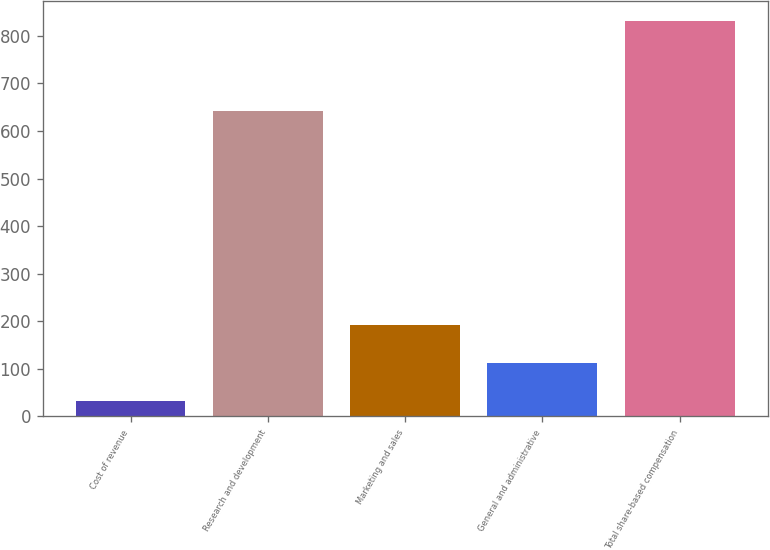<chart> <loc_0><loc_0><loc_500><loc_500><bar_chart><fcel>Cost of revenue<fcel>Research and development<fcel>Marketing and sales<fcel>General and administrative<fcel>Total share-based compensation<nl><fcel>32<fcel>641<fcel>191.8<fcel>111.9<fcel>831<nl></chart> 